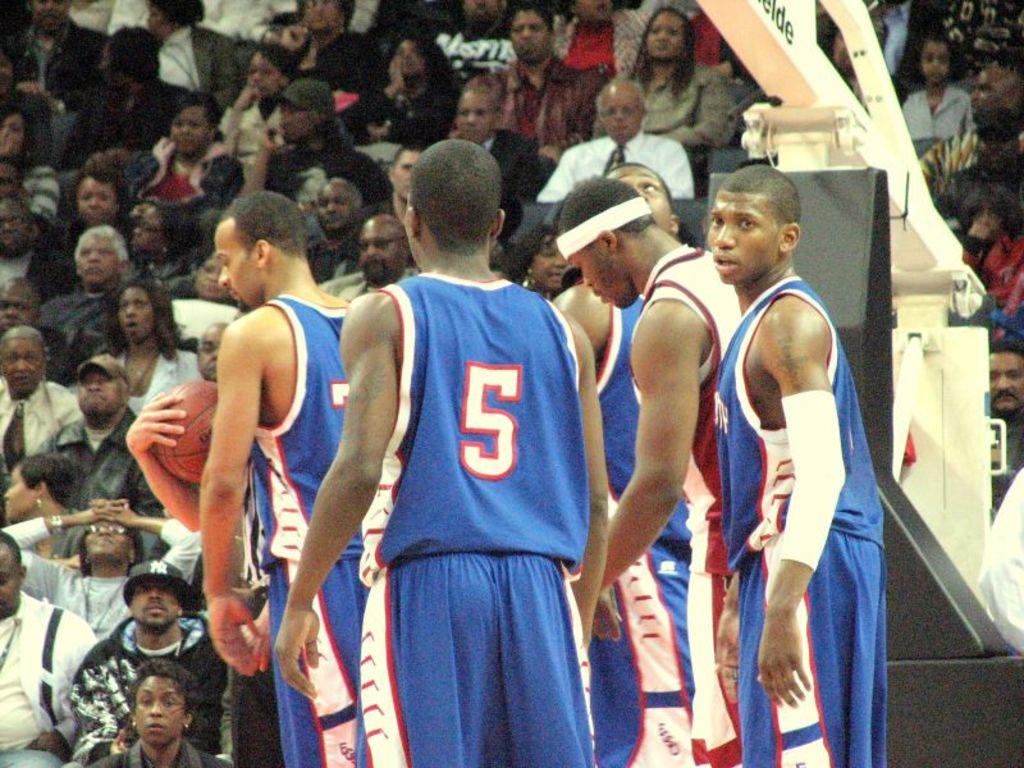<image>
Share a concise interpretation of the image provided. a group of basketball players including number 5 from the blue team standing under a hoop 